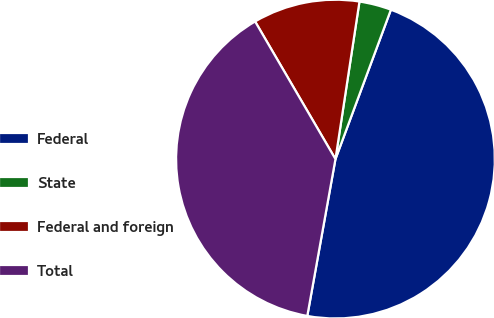Convert chart. <chart><loc_0><loc_0><loc_500><loc_500><pie_chart><fcel>Federal<fcel>State<fcel>Federal and foreign<fcel>Total<nl><fcel>47.17%<fcel>3.25%<fcel>10.82%<fcel>38.76%<nl></chart> 